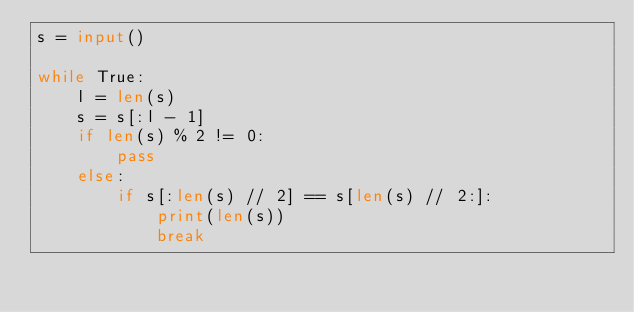<code> <loc_0><loc_0><loc_500><loc_500><_Python_>s = input()

while True:
    l = len(s)
    s = s[:l - 1]
    if len(s) % 2 != 0:
        pass
    else:
        if s[:len(s) // 2] == s[len(s) // 2:]:
            print(len(s))
            break
</code> 